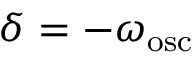<formula> <loc_0><loc_0><loc_500><loc_500>\delta = - \omega _ { o s c }</formula> 